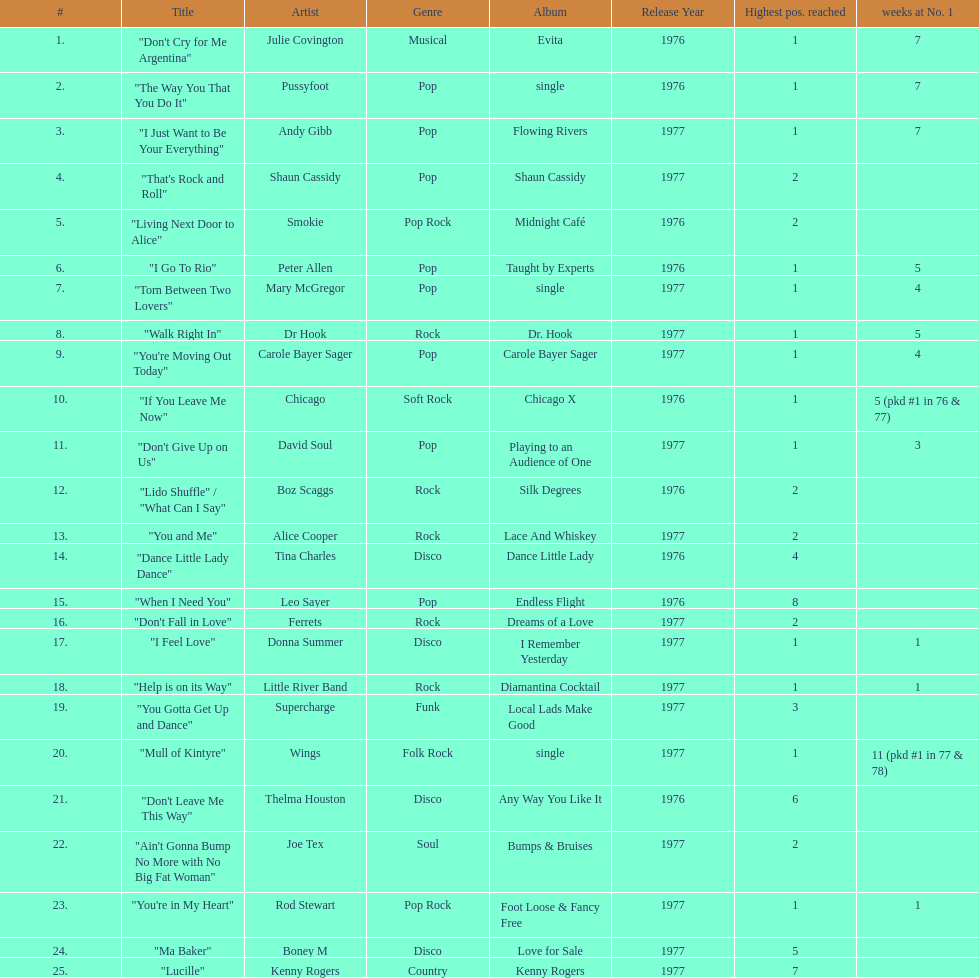How many songs in the table only reached position number 2? 6. 